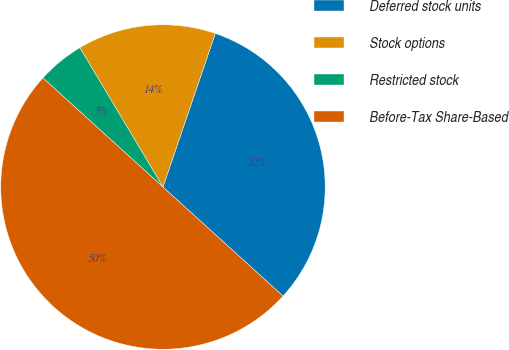Convert chart. <chart><loc_0><loc_0><loc_500><loc_500><pie_chart><fcel>Deferred stock units<fcel>Stock options<fcel>Restricted stock<fcel>Before-Tax Share-Based<nl><fcel>31.51%<fcel>13.79%<fcel>4.7%<fcel>50.0%<nl></chart> 